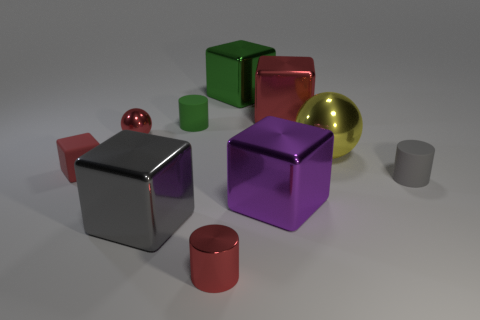Subtract all purple blocks. How many blocks are left? 4 Subtract all large purple cubes. How many cubes are left? 4 Subtract all gray blocks. Subtract all purple cylinders. How many blocks are left? 4 Subtract all balls. How many objects are left? 8 Add 4 tiny red matte things. How many tiny red matte things are left? 5 Add 1 green matte cylinders. How many green matte cylinders exist? 2 Subtract 0 green spheres. How many objects are left? 10 Subtract all small metal cylinders. Subtract all yellow balls. How many objects are left? 8 